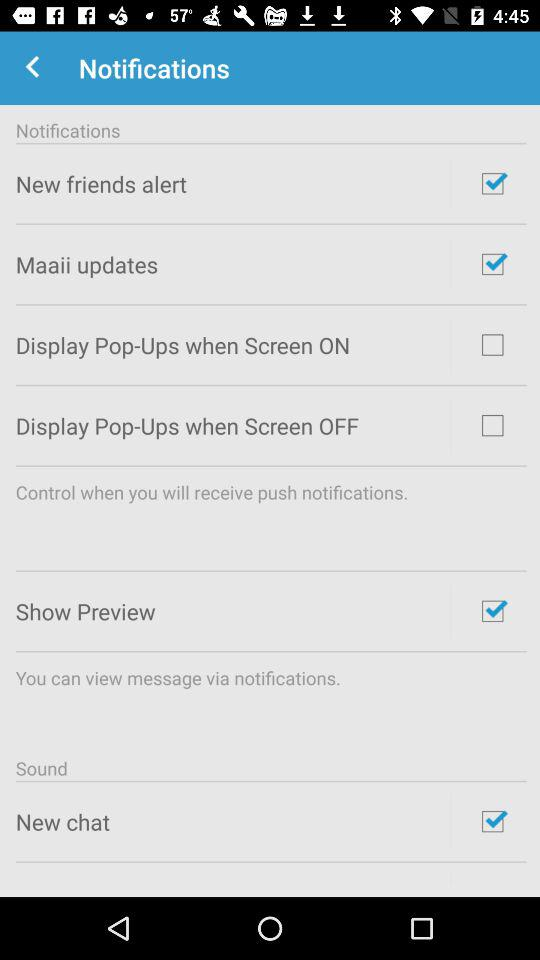What's the status of the "New chat" sound? The status of the "New chat" sound is "on". 